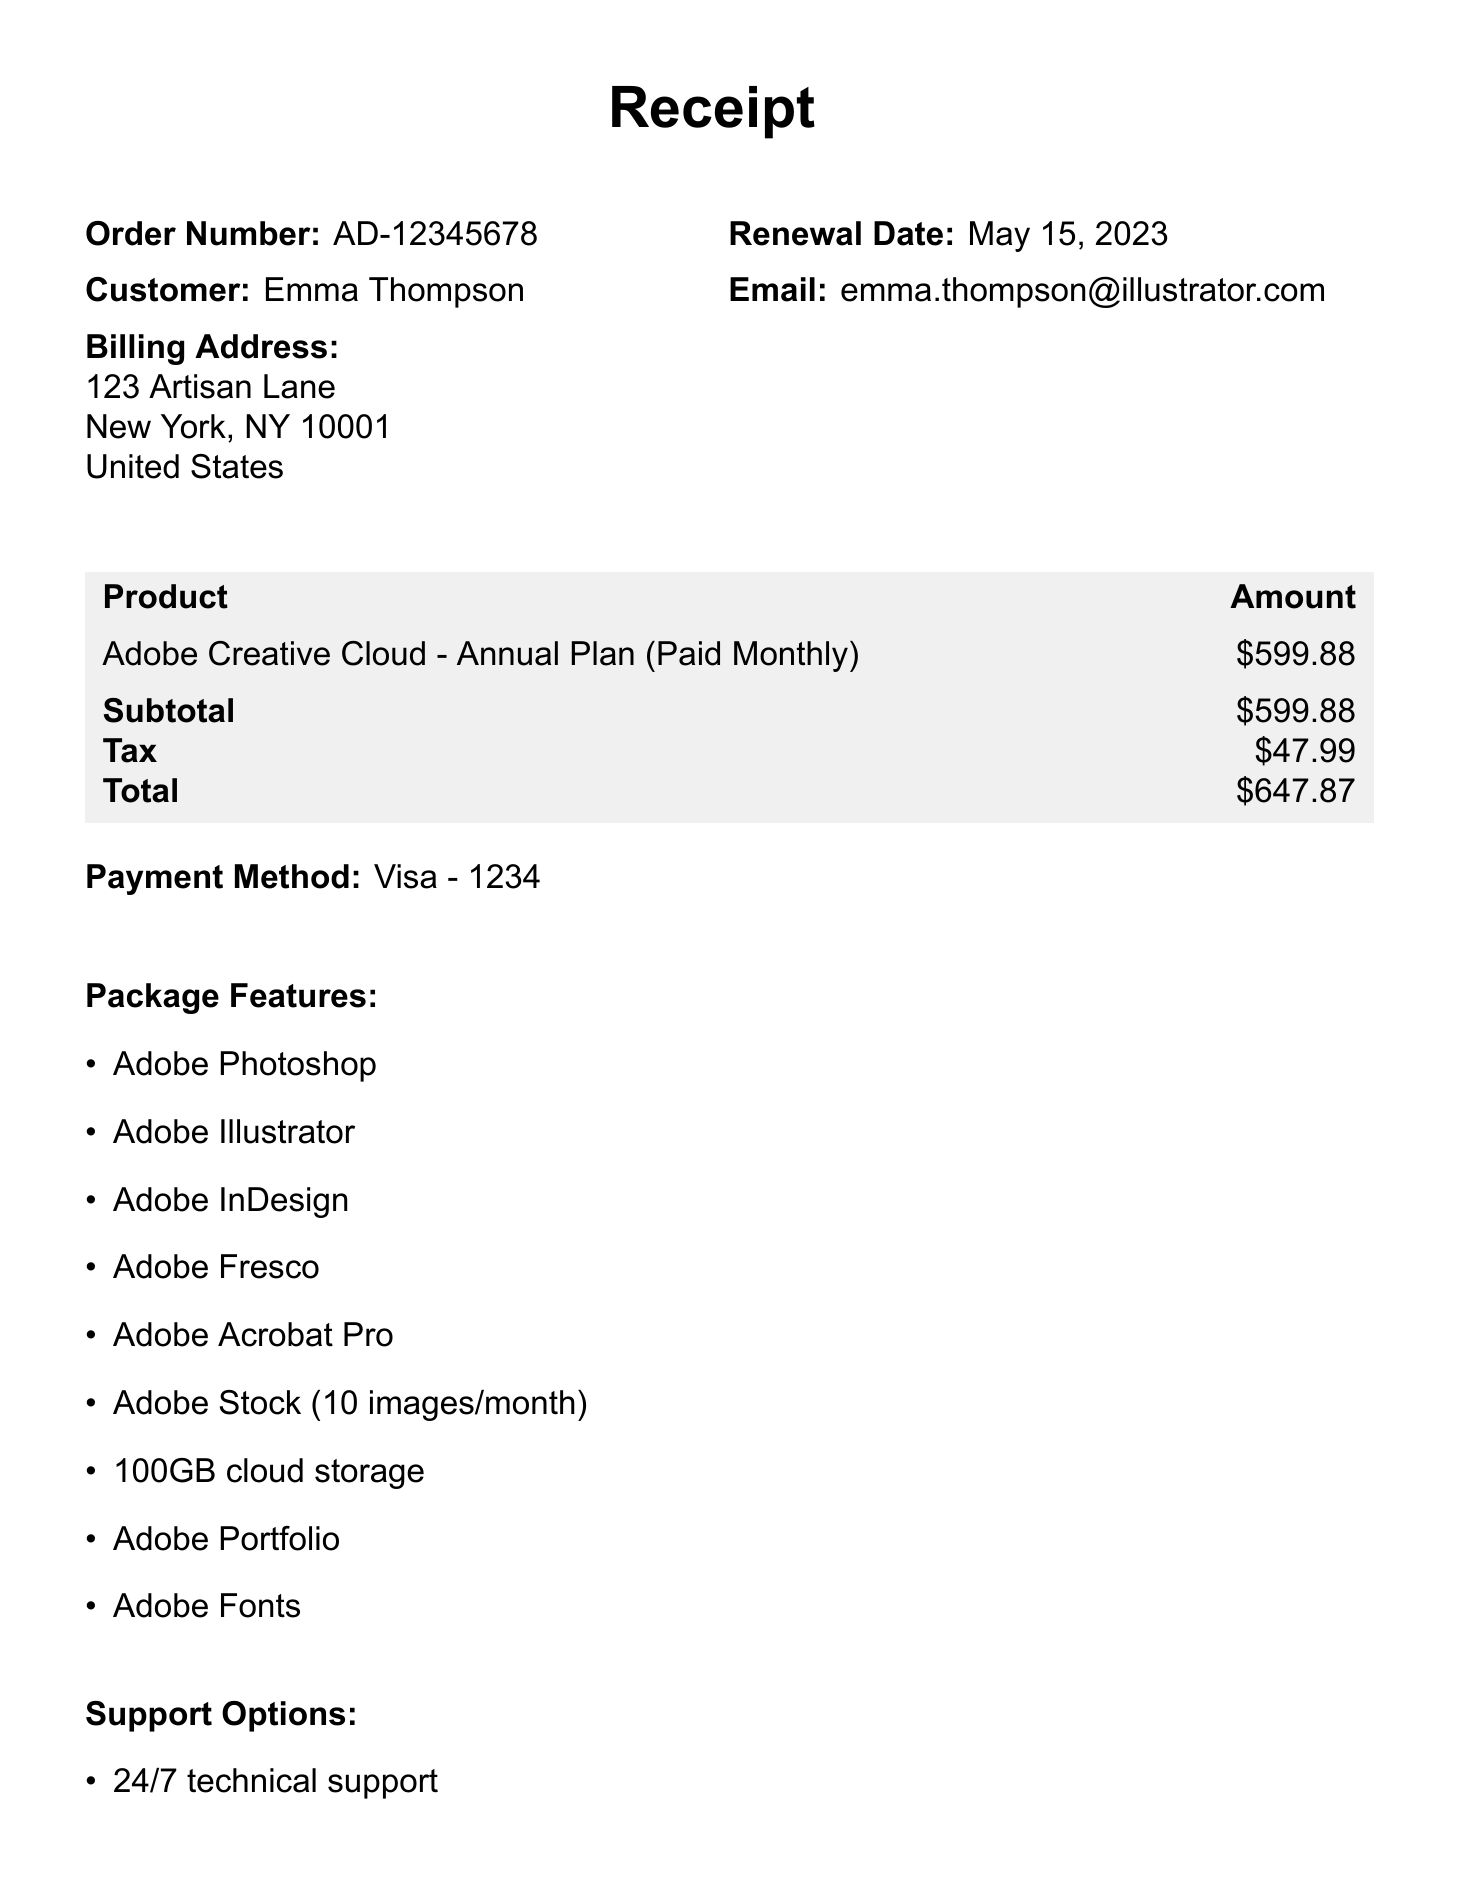What is the company name? The company name is stated at the top of the receipt.
Answer: Adobe Systems Incorporated What is the total amount due? The total amount due is indicated in the payment section of the document.
Answer: $647.87 When is the renewal date? The renewal date for the subscription is provided in the document.
Answer: May 15, 2023 What package features are included? The package features are listed in the relevant section of the receipt.
Answer: Adobe Photoshop, Adobe Illustrator, Adobe InDesign, Adobe Fresco, Adobe Acrobat Pro, Adobe Stock (10 images/month), 100GB cloud storage, Adobe Portfolio, Adobe Fonts What is the tax amount? The tax amount is detailed in the payment section of the receipt.
Answer: $47.99 What payment method was used? The payment method is stated under the payment information in the document.
Answer: Visa - 1234 What is the cancellation policy? The cancellation policy is specifically mentioned in the document.
Answer: Cancel anytime with no cancellation fees. Prorated refund available if canceled within 14 days of renewal What are the support options provided? The support options are enumerated in a specific section of the receipt.
Answer: 24/7 technical support, 1-on-1 Expert Sessions, Unlimited access to Adobe Learn What is the next billing date? The next billing date is mentioned in the receipt under the billing information.
Answer: May 15, 2024 